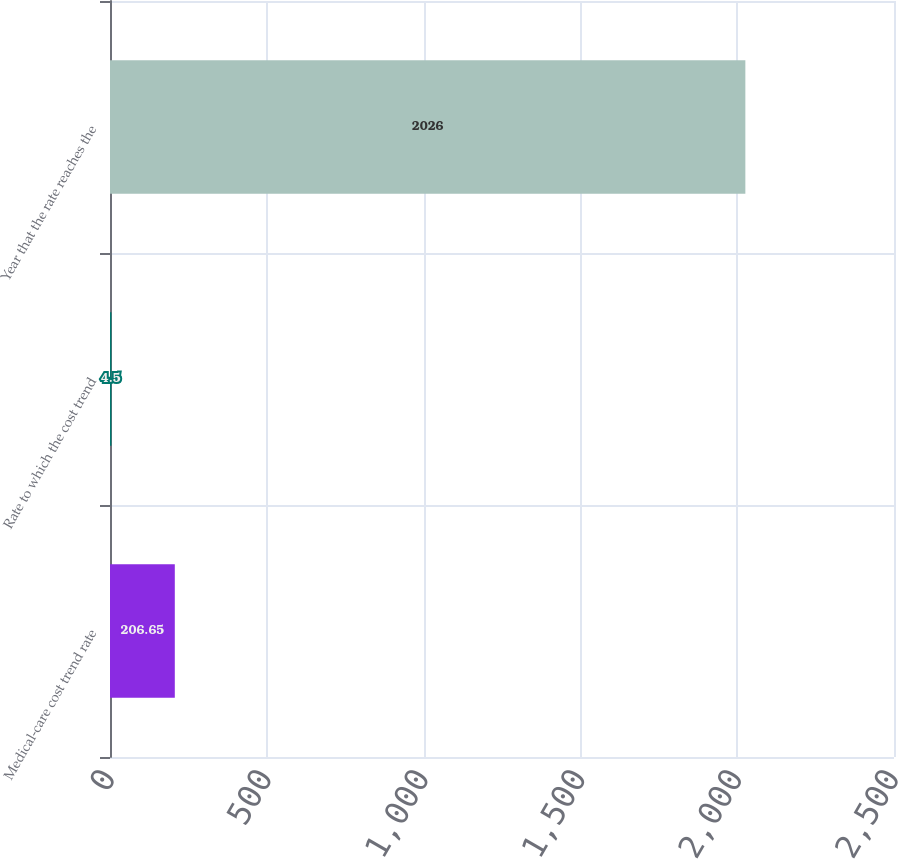Convert chart to OTSL. <chart><loc_0><loc_0><loc_500><loc_500><bar_chart><fcel>Medical-care cost trend rate<fcel>Rate to which the cost trend<fcel>Year that the rate reaches the<nl><fcel>206.65<fcel>4.5<fcel>2026<nl></chart> 